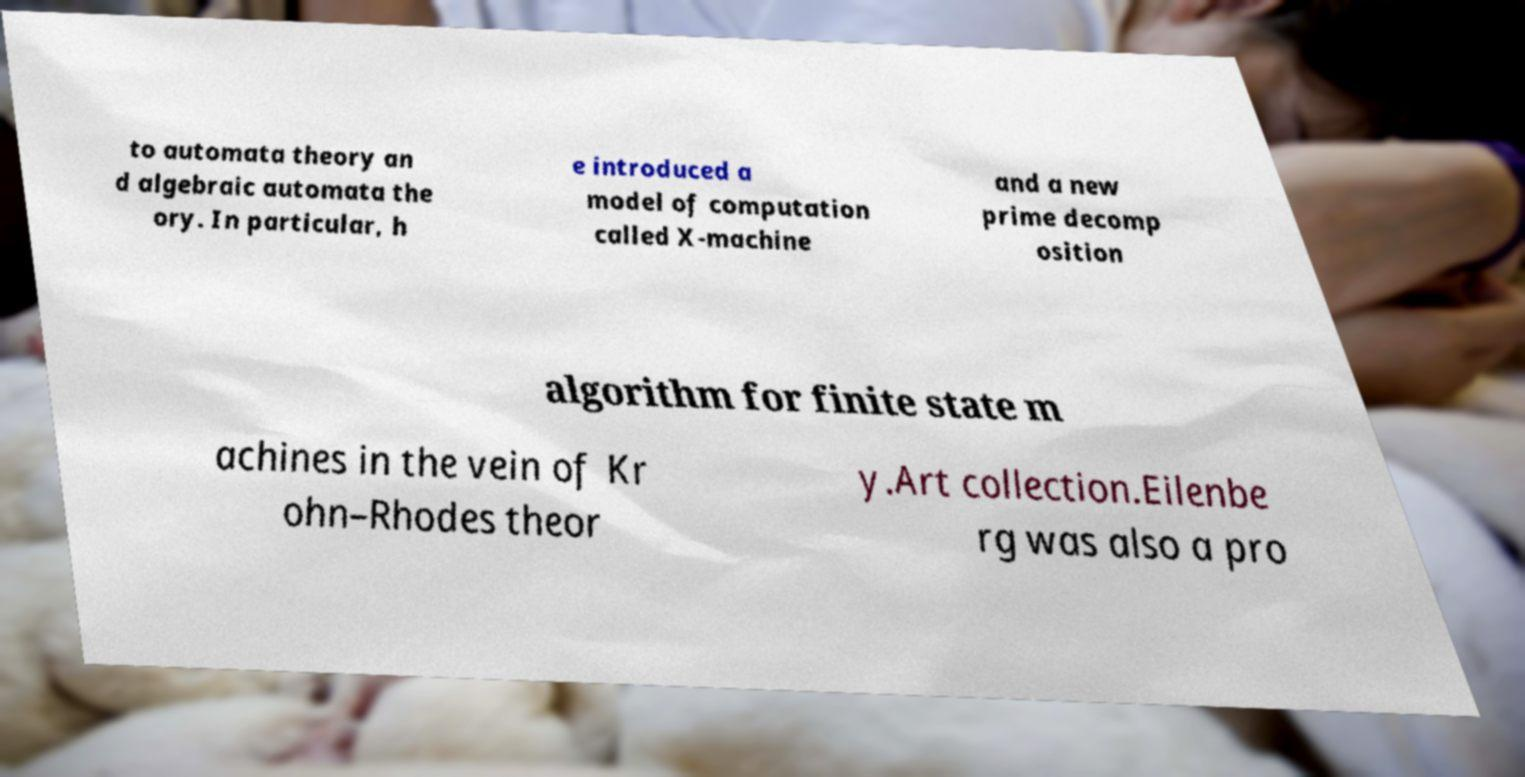Please identify and transcribe the text found in this image. to automata theory an d algebraic automata the ory. In particular, h e introduced a model of computation called X-machine and a new prime decomp osition algorithm for finite state m achines in the vein of Kr ohn–Rhodes theor y.Art collection.Eilenbe rg was also a pro 